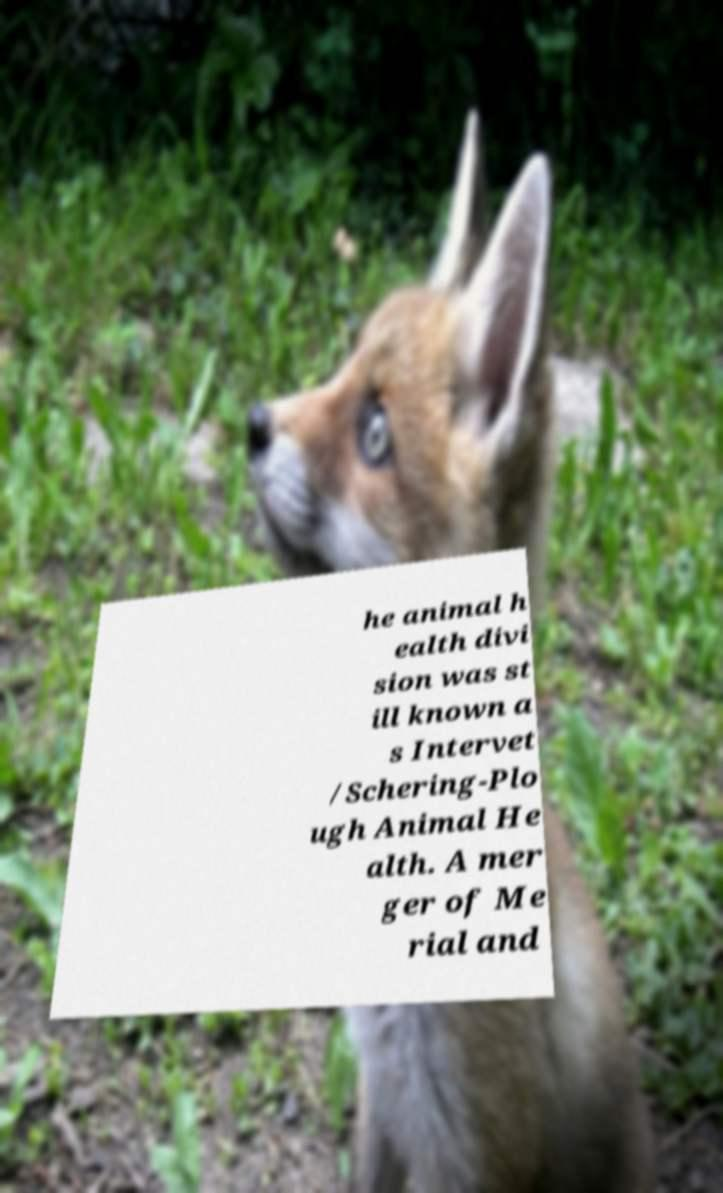For documentation purposes, I need the text within this image transcribed. Could you provide that? he animal h ealth divi sion was st ill known a s Intervet /Schering-Plo ugh Animal He alth. A mer ger of Me rial and 